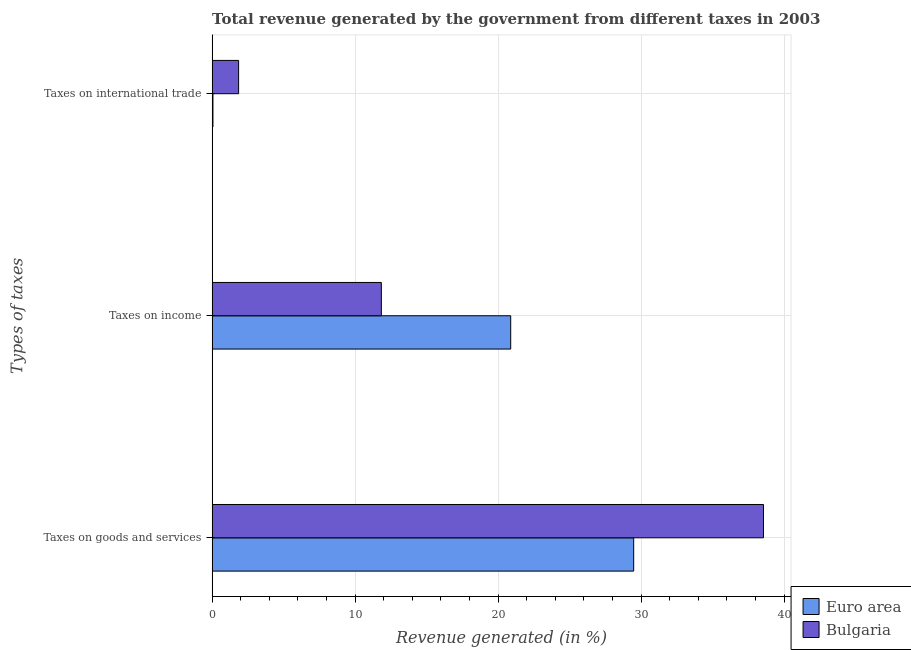How many different coloured bars are there?
Give a very brief answer. 2. How many bars are there on the 2nd tick from the top?
Your answer should be very brief. 2. What is the label of the 3rd group of bars from the top?
Your answer should be compact. Taxes on goods and services. What is the percentage of revenue generated by taxes on income in Bulgaria?
Your answer should be compact. 11.83. Across all countries, what is the maximum percentage of revenue generated by tax on international trade?
Your answer should be very brief. 1.85. Across all countries, what is the minimum percentage of revenue generated by taxes on income?
Your response must be concise. 11.83. In which country was the percentage of revenue generated by taxes on income minimum?
Give a very brief answer. Bulgaria. What is the total percentage of revenue generated by tax on international trade in the graph?
Provide a succinct answer. 1.91. What is the difference between the percentage of revenue generated by tax on international trade in Bulgaria and that in Euro area?
Keep it short and to the point. 1.79. What is the difference between the percentage of revenue generated by tax on international trade in Euro area and the percentage of revenue generated by taxes on income in Bulgaria?
Provide a succinct answer. -11.78. What is the average percentage of revenue generated by tax on international trade per country?
Make the answer very short. 0.96. What is the difference between the percentage of revenue generated by taxes on income and percentage of revenue generated by tax on international trade in Euro area?
Keep it short and to the point. 20.82. What is the ratio of the percentage of revenue generated by taxes on goods and services in Bulgaria to that in Euro area?
Your answer should be compact. 1.31. Is the difference between the percentage of revenue generated by taxes on goods and services in Bulgaria and Euro area greater than the difference between the percentage of revenue generated by tax on international trade in Bulgaria and Euro area?
Keep it short and to the point. Yes. What is the difference between the highest and the second highest percentage of revenue generated by tax on international trade?
Provide a short and direct response. 1.79. What is the difference between the highest and the lowest percentage of revenue generated by taxes on income?
Provide a short and direct response. 9.05. Is the sum of the percentage of revenue generated by taxes on income in Euro area and Bulgaria greater than the maximum percentage of revenue generated by taxes on goods and services across all countries?
Keep it short and to the point. No. What does the 2nd bar from the top in Taxes on goods and services represents?
Offer a very short reply. Euro area. Are all the bars in the graph horizontal?
Your answer should be very brief. Yes. How many countries are there in the graph?
Your response must be concise. 2. What is the difference between two consecutive major ticks on the X-axis?
Keep it short and to the point. 10. Are the values on the major ticks of X-axis written in scientific E-notation?
Make the answer very short. No. Where does the legend appear in the graph?
Your answer should be compact. Bottom right. How are the legend labels stacked?
Provide a succinct answer. Vertical. What is the title of the graph?
Your answer should be compact. Total revenue generated by the government from different taxes in 2003. What is the label or title of the X-axis?
Your answer should be compact. Revenue generated (in %). What is the label or title of the Y-axis?
Provide a short and direct response. Types of taxes. What is the Revenue generated (in %) of Euro area in Taxes on goods and services?
Keep it short and to the point. 29.48. What is the Revenue generated (in %) of Bulgaria in Taxes on goods and services?
Make the answer very short. 38.55. What is the Revenue generated (in %) of Euro area in Taxes on income?
Offer a terse response. 20.88. What is the Revenue generated (in %) of Bulgaria in Taxes on income?
Ensure brevity in your answer.  11.83. What is the Revenue generated (in %) of Euro area in Taxes on international trade?
Provide a short and direct response. 0.06. What is the Revenue generated (in %) of Bulgaria in Taxes on international trade?
Offer a terse response. 1.85. Across all Types of taxes, what is the maximum Revenue generated (in %) in Euro area?
Your response must be concise. 29.48. Across all Types of taxes, what is the maximum Revenue generated (in %) in Bulgaria?
Give a very brief answer. 38.55. Across all Types of taxes, what is the minimum Revenue generated (in %) in Euro area?
Offer a very short reply. 0.06. Across all Types of taxes, what is the minimum Revenue generated (in %) of Bulgaria?
Your answer should be very brief. 1.85. What is the total Revenue generated (in %) in Euro area in the graph?
Give a very brief answer. 50.41. What is the total Revenue generated (in %) in Bulgaria in the graph?
Provide a short and direct response. 52.24. What is the difference between the Revenue generated (in %) in Euro area in Taxes on goods and services and that in Taxes on income?
Make the answer very short. 8.6. What is the difference between the Revenue generated (in %) in Bulgaria in Taxes on goods and services and that in Taxes on income?
Ensure brevity in your answer.  26.72. What is the difference between the Revenue generated (in %) in Euro area in Taxes on goods and services and that in Taxes on international trade?
Offer a very short reply. 29.42. What is the difference between the Revenue generated (in %) of Bulgaria in Taxes on goods and services and that in Taxes on international trade?
Keep it short and to the point. 36.7. What is the difference between the Revenue generated (in %) of Euro area in Taxes on income and that in Taxes on international trade?
Provide a succinct answer. 20.82. What is the difference between the Revenue generated (in %) of Bulgaria in Taxes on income and that in Taxes on international trade?
Keep it short and to the point. 9.98. What is the difference between the Revenue generated (in %) of Euro area in Taxes on goods and services and the Revenue generated (in %) of Bulgaria in Taxes on income?
Your answer should be compact. 17.64. What is the difference between the Revenue generated (in %) of Euro area in Taxes on goods and services and the Revenue generated (in %) of Bulgaria in Taxes on international trade?
Your answer should be compact. 27.62. What is the difference between the Revenue generated (in %) of Euro area in Taxes on income and the Revenue generated (in %) of Bulgaria in Taxes on international trade?
Your response must be concise. 19.03. What is the average Revenue generated (in %) of Euro area per Types of taxes?
Provide a succinct answer. 16.8. What is the average Revenue generated (in %) of Bulgaria per Types of taxes?
Offer a terse response. 17.41. What is the difference between the Revenue generated (in %) of Euro area and Revenue generated (in %) of Bulgaria in Taxes on goods and services?
Provide a short and direct response. -9.08. What is the difference between the Revenue generated (in %) in Euro area and Revenue generated (in %) in Bulgaria in Taxes on income?
Keep it short and to the point. 9.05. What is the difference between the Revenue generated (in %) of Euro area and Revenue generated (in %) of Bulgaria in Taxes on international trade?
Your answer should be very brief. -1.79. What is the ratio of the Revenue generated (in %) in Euro area in Taxes on goods and services to that in Taxes on income?
Provide a short and direct response. 1.41. What is the ratio of the Revenue generated (in %) of Bulgaria in Taxes on goods and services to that in Taxes on income?
Offer a very short reply. 3.26. What is the ratio of the Revenue generated (in %) of Euro area in Taxes on goods and services to that in Taxes on international trade?
Make the answer very short. 511.62. What is the ratio of the Revenue generated (in %) of Bulgaria in Taxes on goods and services to that in Taxes on international trade?
Keep it short and to the point. 20.81. What is the ratio of the Revenue generated (in %) of Euro area in Taxes on income to that in Taxes on international trade?
Offer a very short reply. 362.37. What is the ratio of the Revenue generated (in %) of Bulgaria in Taxes on income to that in Taxes on international trade?
Keep it short and to the point. 6.39. What is the difference between the highest and the second highest Revenue generated (in %) of Euro area?
Your response must be concise. 8.6. What is the difference between the highest and the second highest Revenue generated (in %) in Bulgaria?
Your answer should be very brief. 26.72. What is the difference between the highest and the lowest Revenue generated (in %) of Euro area?
Make the answer very short. 29.42. What is the difference between the highest and the lowest Revenue generated (in %) of Bulgaria?
Your response must be concise. 36.7. 